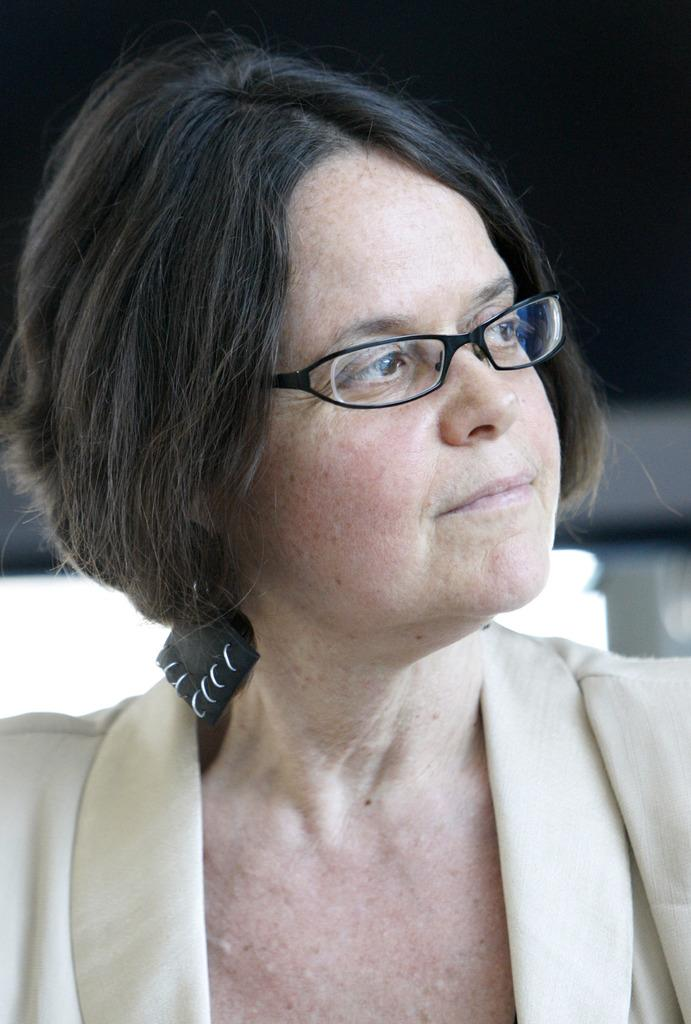Who is present in the image? There is a woman in the image. What accessory is the woman wearing? The woman is wearing glasses (specs) in the image. Can you describe the background of the image? The background of the image is blurry. How many feathers can be seen on the owl in the image? There is no owl present in the image, so it is not possible to determine the number of feathers. 